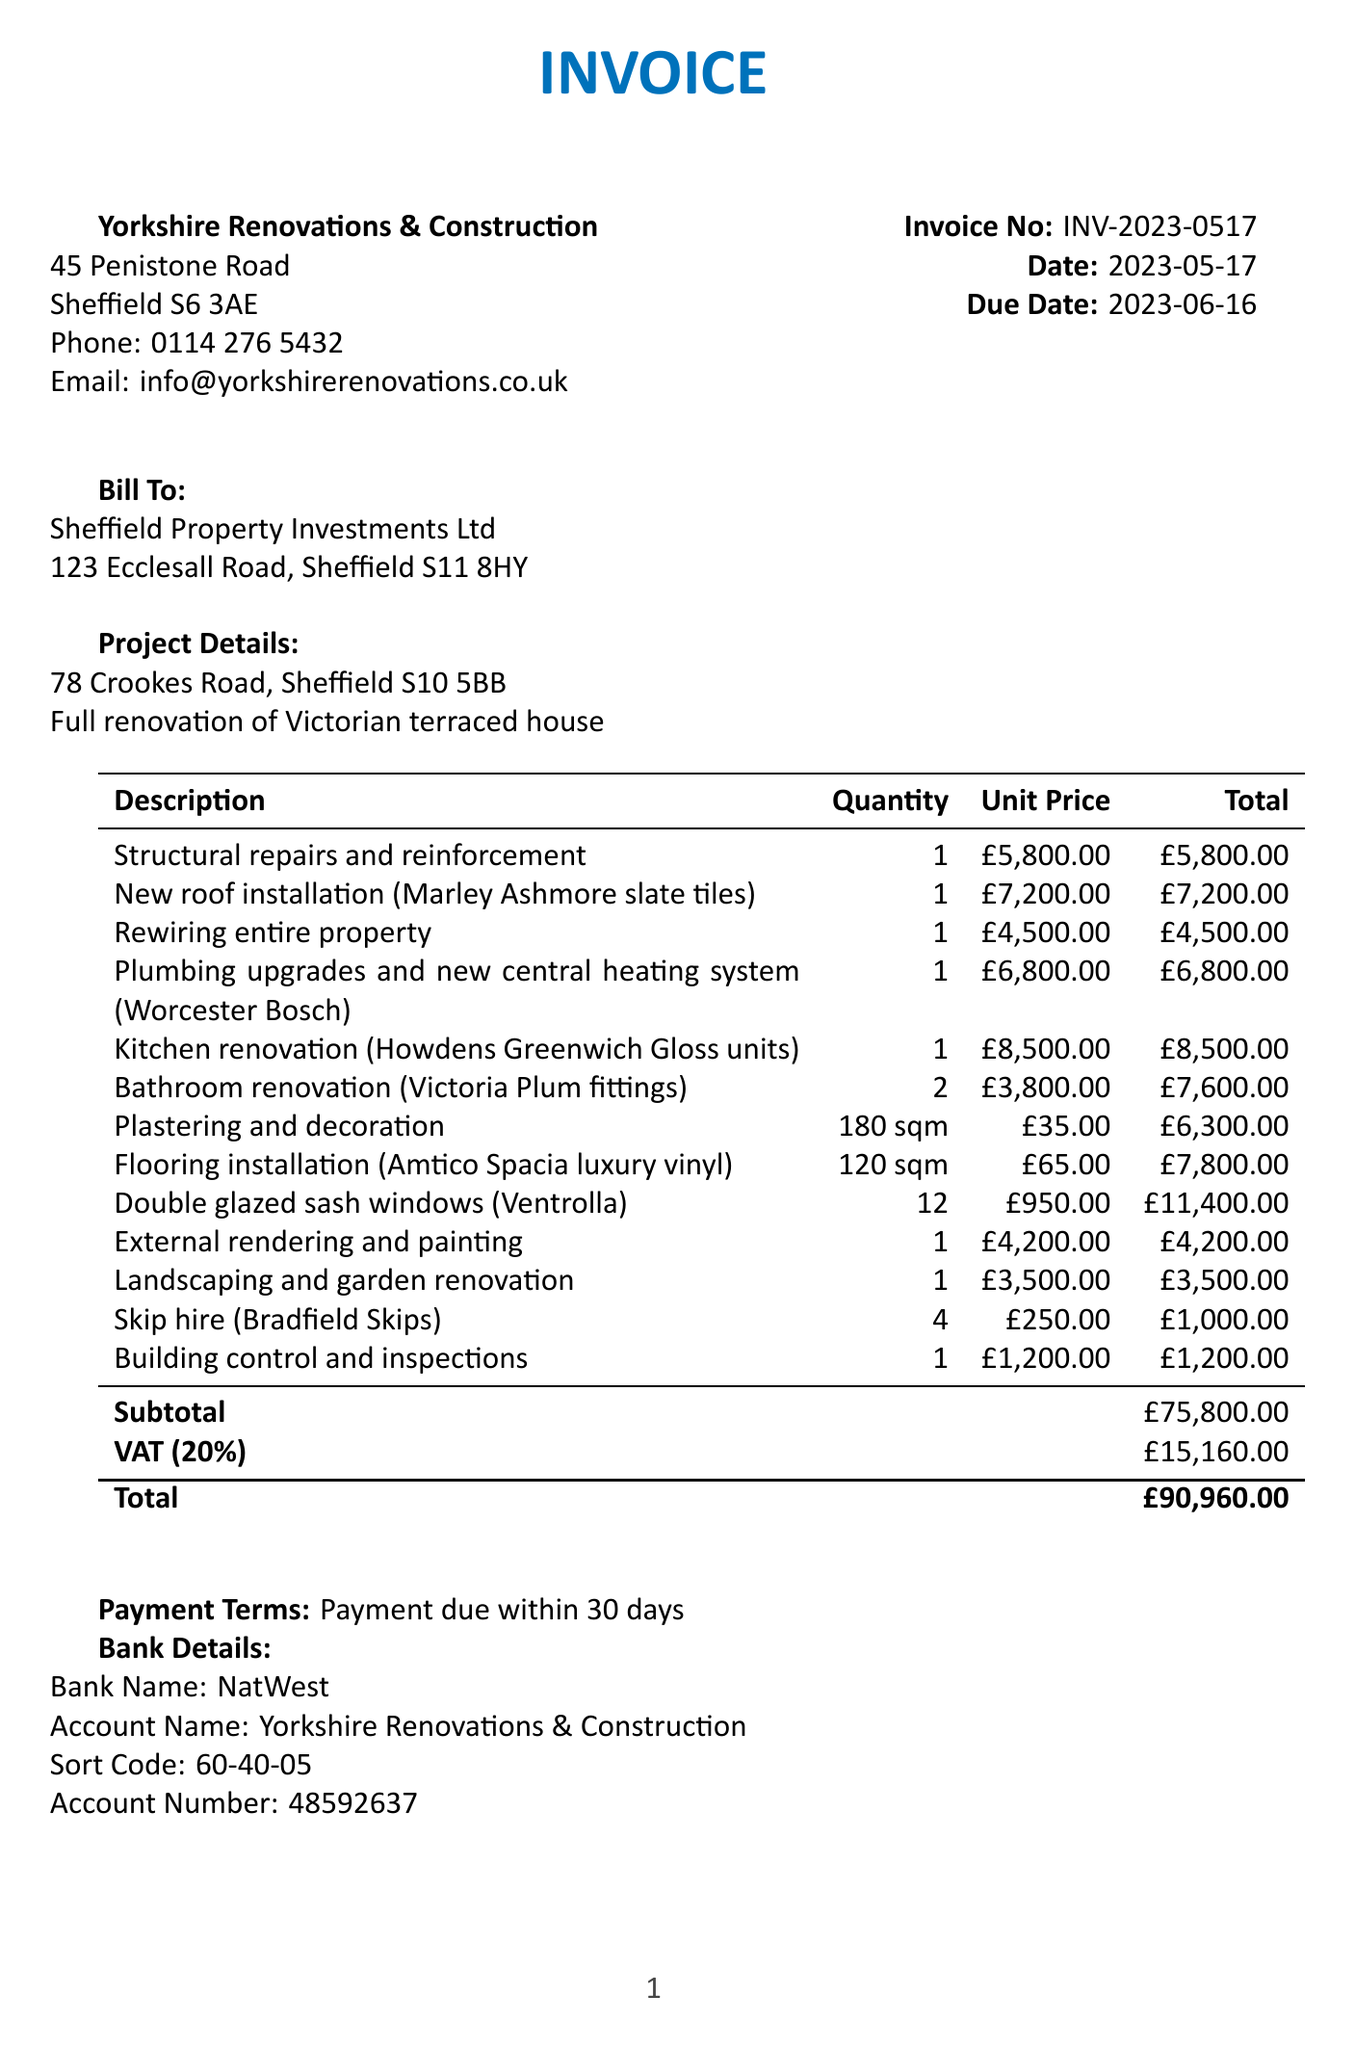What is the invoice number? The invoice number is listed at the top of the document under 'Invoice No', which is INV-2023-0517.
Answer: INV-2023-0517 What is the due date for the invoice? The due date is indicated in the document and is one month after the invoice date, which is 2023-06-16.
Answer: 2023-06-16 Who is the contractor for the renovation project? The contractor's name is listed in the document, which is Yorkshire Renovations & Construction.
Answer: Yorkshire Renovations & Construction How much is the total cost of the renovation project? The total cost is highlighted at the bottom of the invoice, which includes all materials, labor, and VAT, amounting to £90,960.00.
Answer: £90,960.00 What is the total amount allocated for double glazed sash windows? The cost for double glazed sash windows is specifically mentioned under line items, totaling £11,400.00.
Answer: £11,400.00 How many units of bathroom renovation are included in the invoice? The invoice states that there are 2 units for the bathroom renovation line item.
Answer: 2 What is the VAT rate applied to this invoice? The VAT rate for the costs is specified as 20% in the document.
Answer: 20% What is the payment term specified in the invoice? The payment terms are stated in the invoice, which indicates payment is due within 30 days.
Answer: Payment due within 30 days What type of property is being renovated? The project description specifies that it is a full renovation of a Victorian terraced house.
Answer: Victorian terraced house 